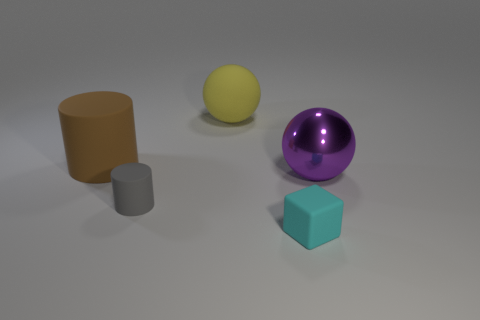Add 5 tiny cyan things. How many objects exist? 10 Subtract all cylinders. How many objects are left? 3 Add 2 big cyan objects. How many big cyan objects exist? 2 Subtract 1 cyan blocks. How many objects are left? 4 Subtract all purple cylinders. Subtract all yellow things. How many objects are left? 4 Add 1 small rubber things. How many small rubber things are left? 3 